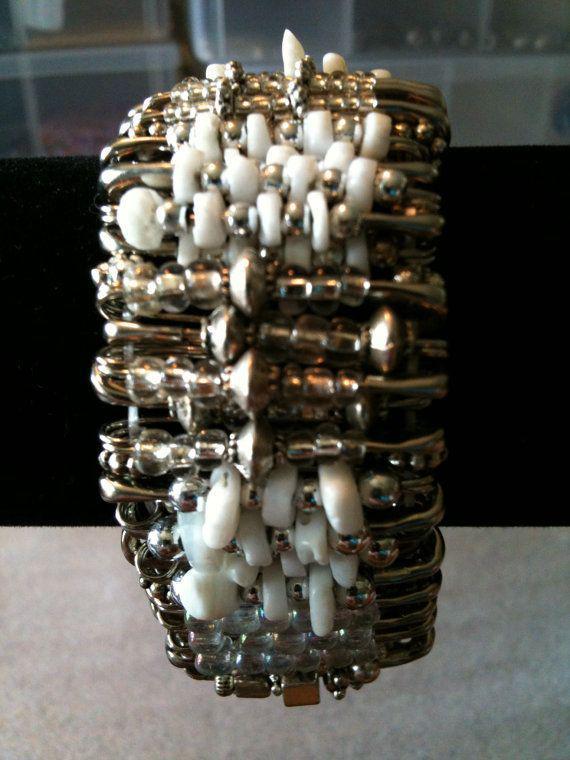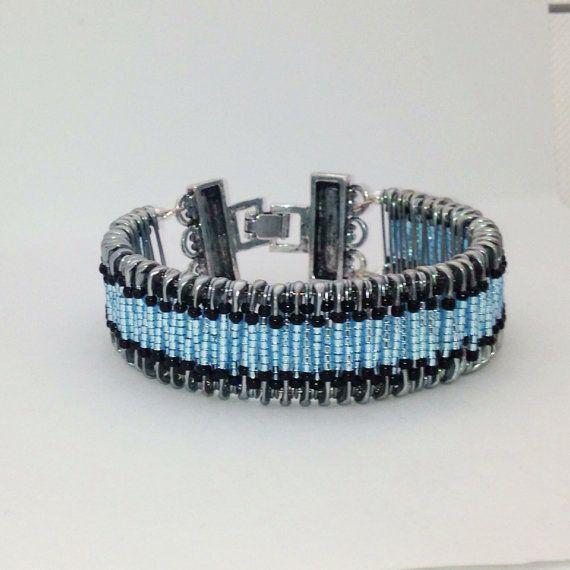The first image is the image on the left, the second image is the image on the right. Given the left and right images, does the statement "The bracelet in the image on the right uses a clasp to close." hold true? Answer yes or no. Yes. The first image is the image on the left, the second image is the image on the right. Analyze the images presented: Is the assertion "All images are bracelets sitting the same position on a plain, solid colored surface." valid? Answer yes or no. No. 